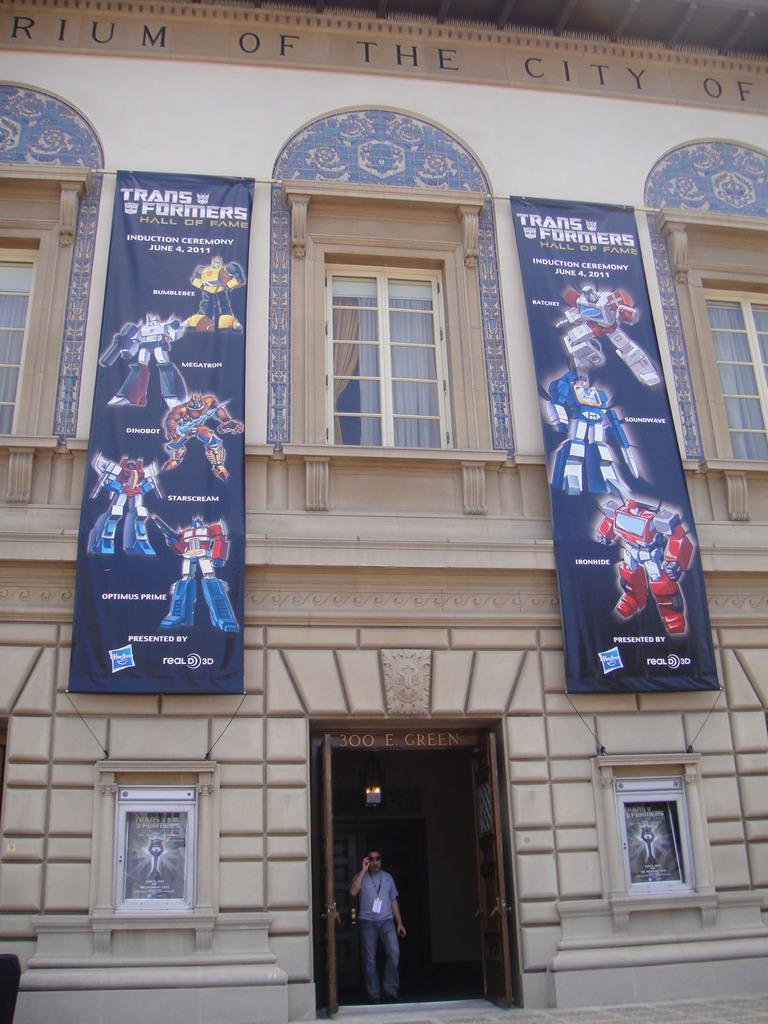Can you describe this image briefly? In the foreground I can see a building, boards, posters, windows, person and a door. This image is taken may be outside the building. 